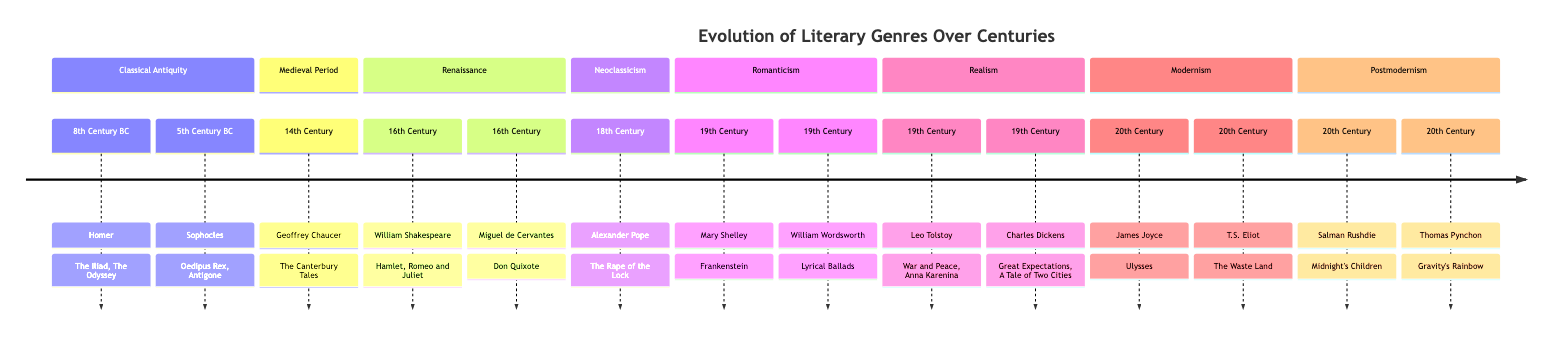What is the first literary work listed in the Classical Antiquity section? The first literary work in the Classical Antiquity section is "The Iliad," written by Homer in the 8th Century BC.
Answer: The Iliad Who wrote "Frankenstein"? "Frankenstein" was written by Mary Shelley during the Romanticism movement in the 19th Century.
Answer: Mary Shelley How many authors are listed in the Modernism section? In the Modernism section, there are two authors listed: James Joyce and T.S. Eliot.
Answer: 2 Which literary period includes "Hamlet"? "Hamlet" is part of the Renaissance literary period, written by William Shakespeare in the 16th Century.
Answer: Renaissance Name one work from the Neoclassicism section. One work from the Neoclassicism section is "The Rape of the Lock," written by Alexander Pope in the 18th Century.
Answer: The Rape of the Lock Which genre had a milestone in the 20th Century represented by "Midnight's Children"? "Midnight's Children" represents the Postmodernism genre and is associated with the 20th Century.
Answer: Postmodernism How many literary movements are represented in the diagram? There are seven literary movements represented in the diagram: Classical Antiquity, Medieval Period, Renaissance, Neoclassicism, Romanticism, Realism, Modernism, and Postmodernism.
Answer: 7 Which author wrote works during the 19th Century? The authors who wrote works during the 19th Century include Mary Shelley, Leo Tolstoy, and Charles Dickens.
Answer: Mary Shelley, Leo Tolstoy, Charles Dickens What is the last literary work mentioned in the diagram? The last literary work mentioned in the diagram is "Gravity's Rainbow," written by Thomas Pynchon in the 20th Century.
Answer: Gravity's Rainbow 